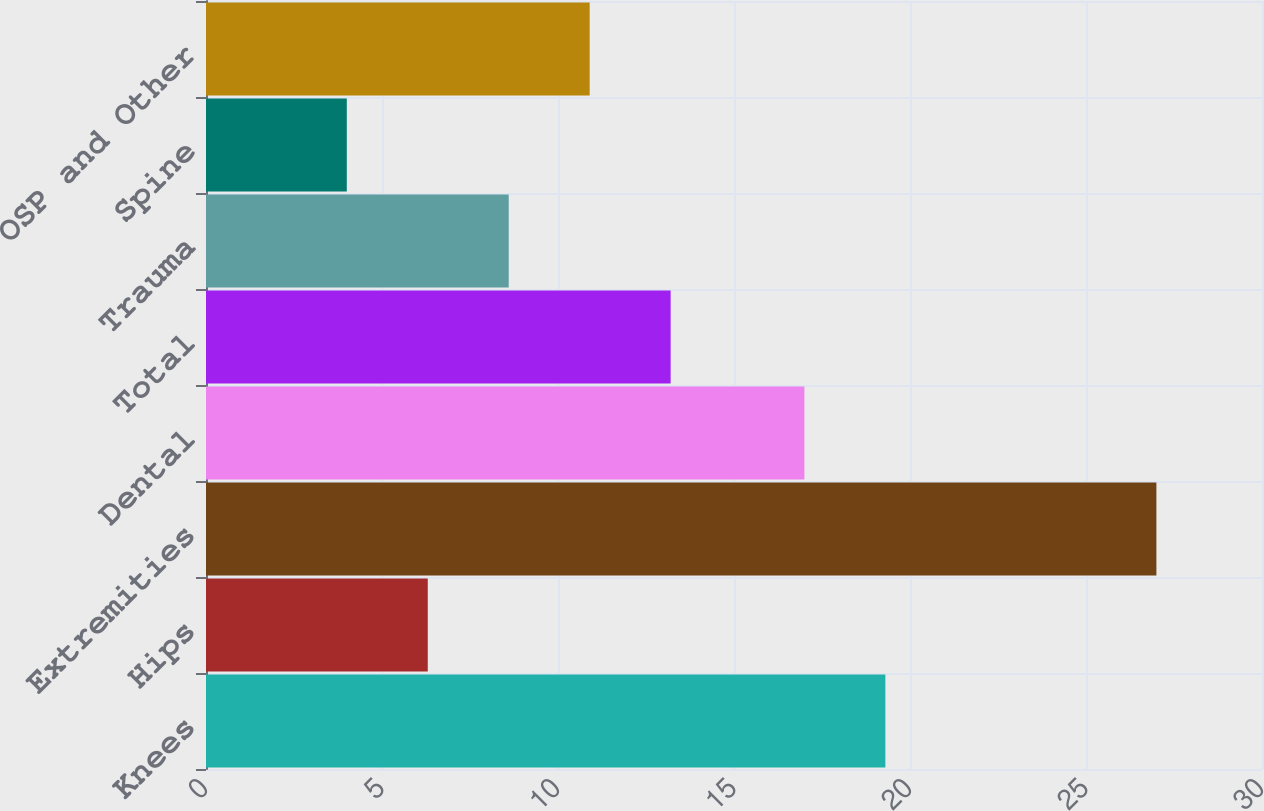Convert chart. <chart><loc_0><loc_0><loc_500><loc_500><bar_chart><fcel>Knees<fcel>Hips<fcel>Extremities<fcel>Dental<fcel>Total<fcel>Trauma<fcel>Spine<fcel>OSP and Other<nl><fcel>19.3<fcel>6.3<fcel>27<fcel>17<fcel>13.2<fcel>8.6<fcel>4<fcel>10.9<nl></chart> 